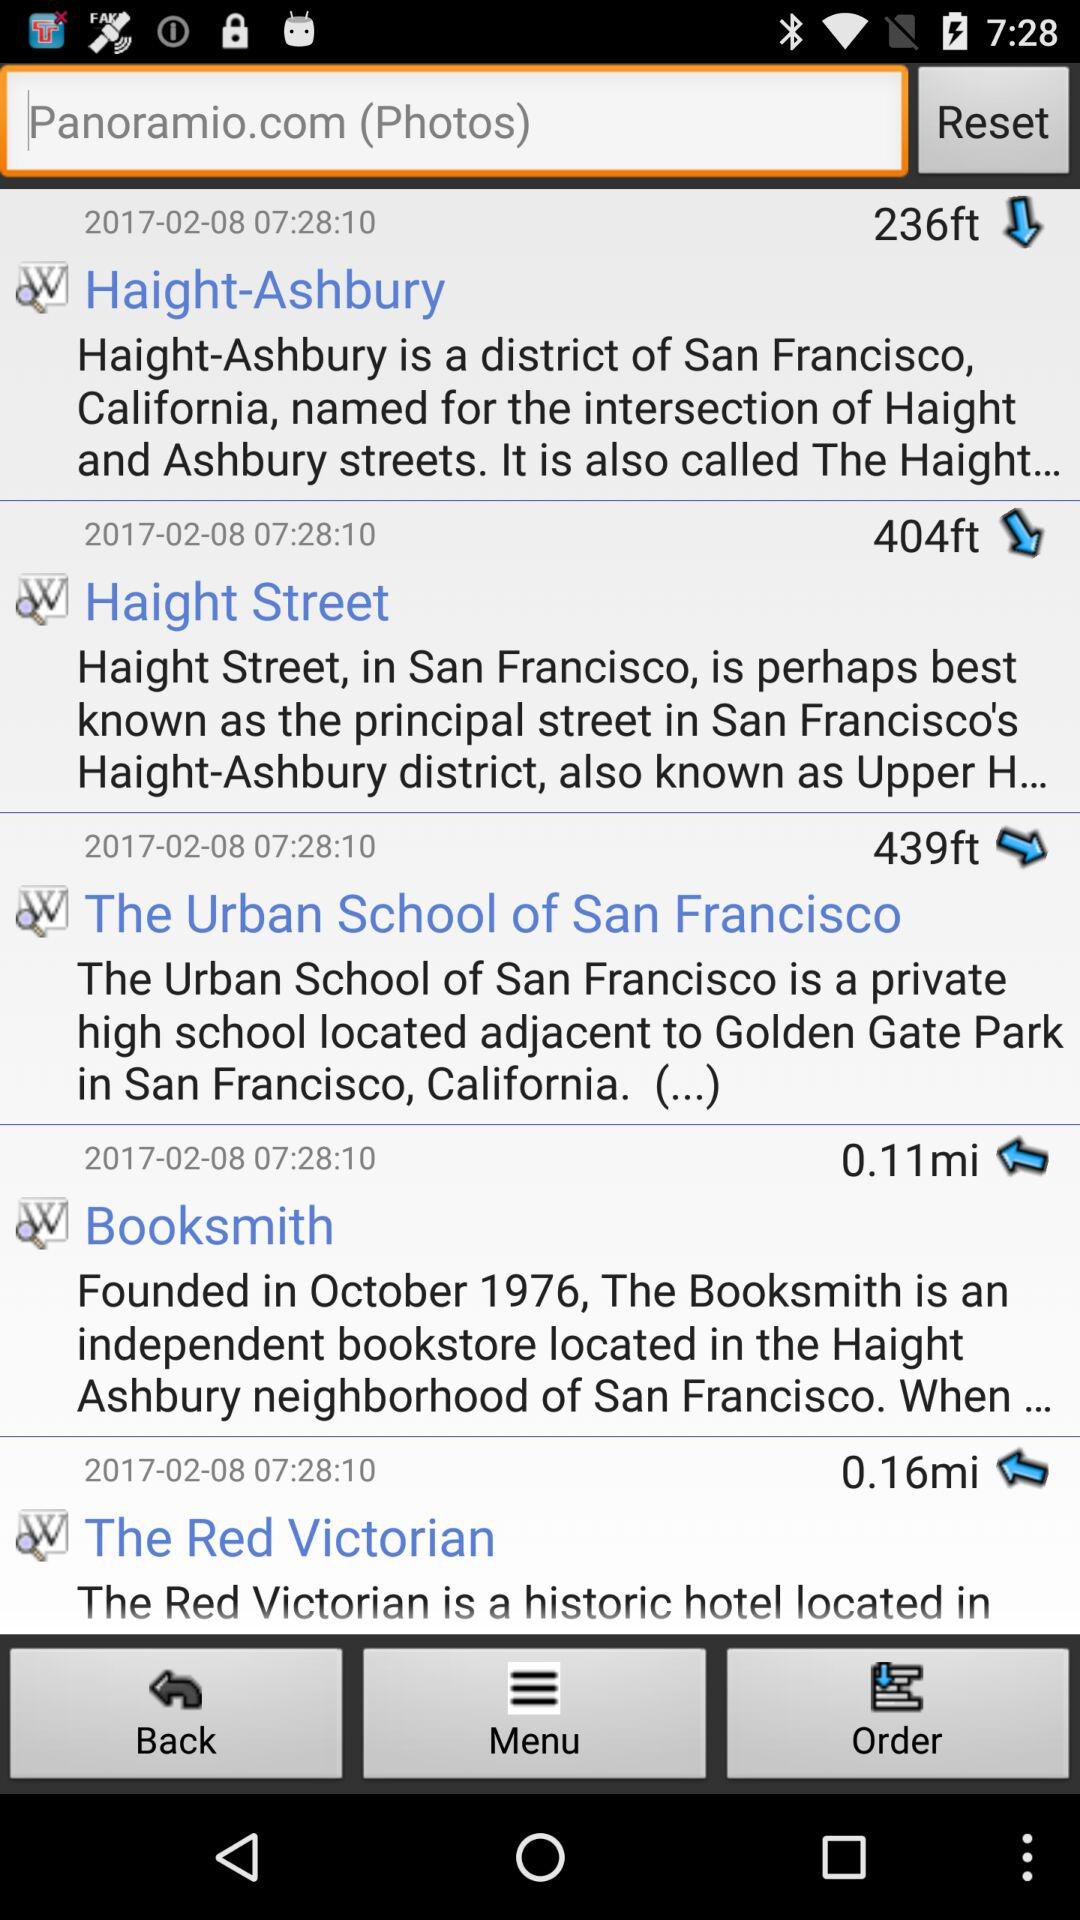What is the altitude of Haight-Ashbury? The altitude of Haight-Ashbury is 236 feet. 